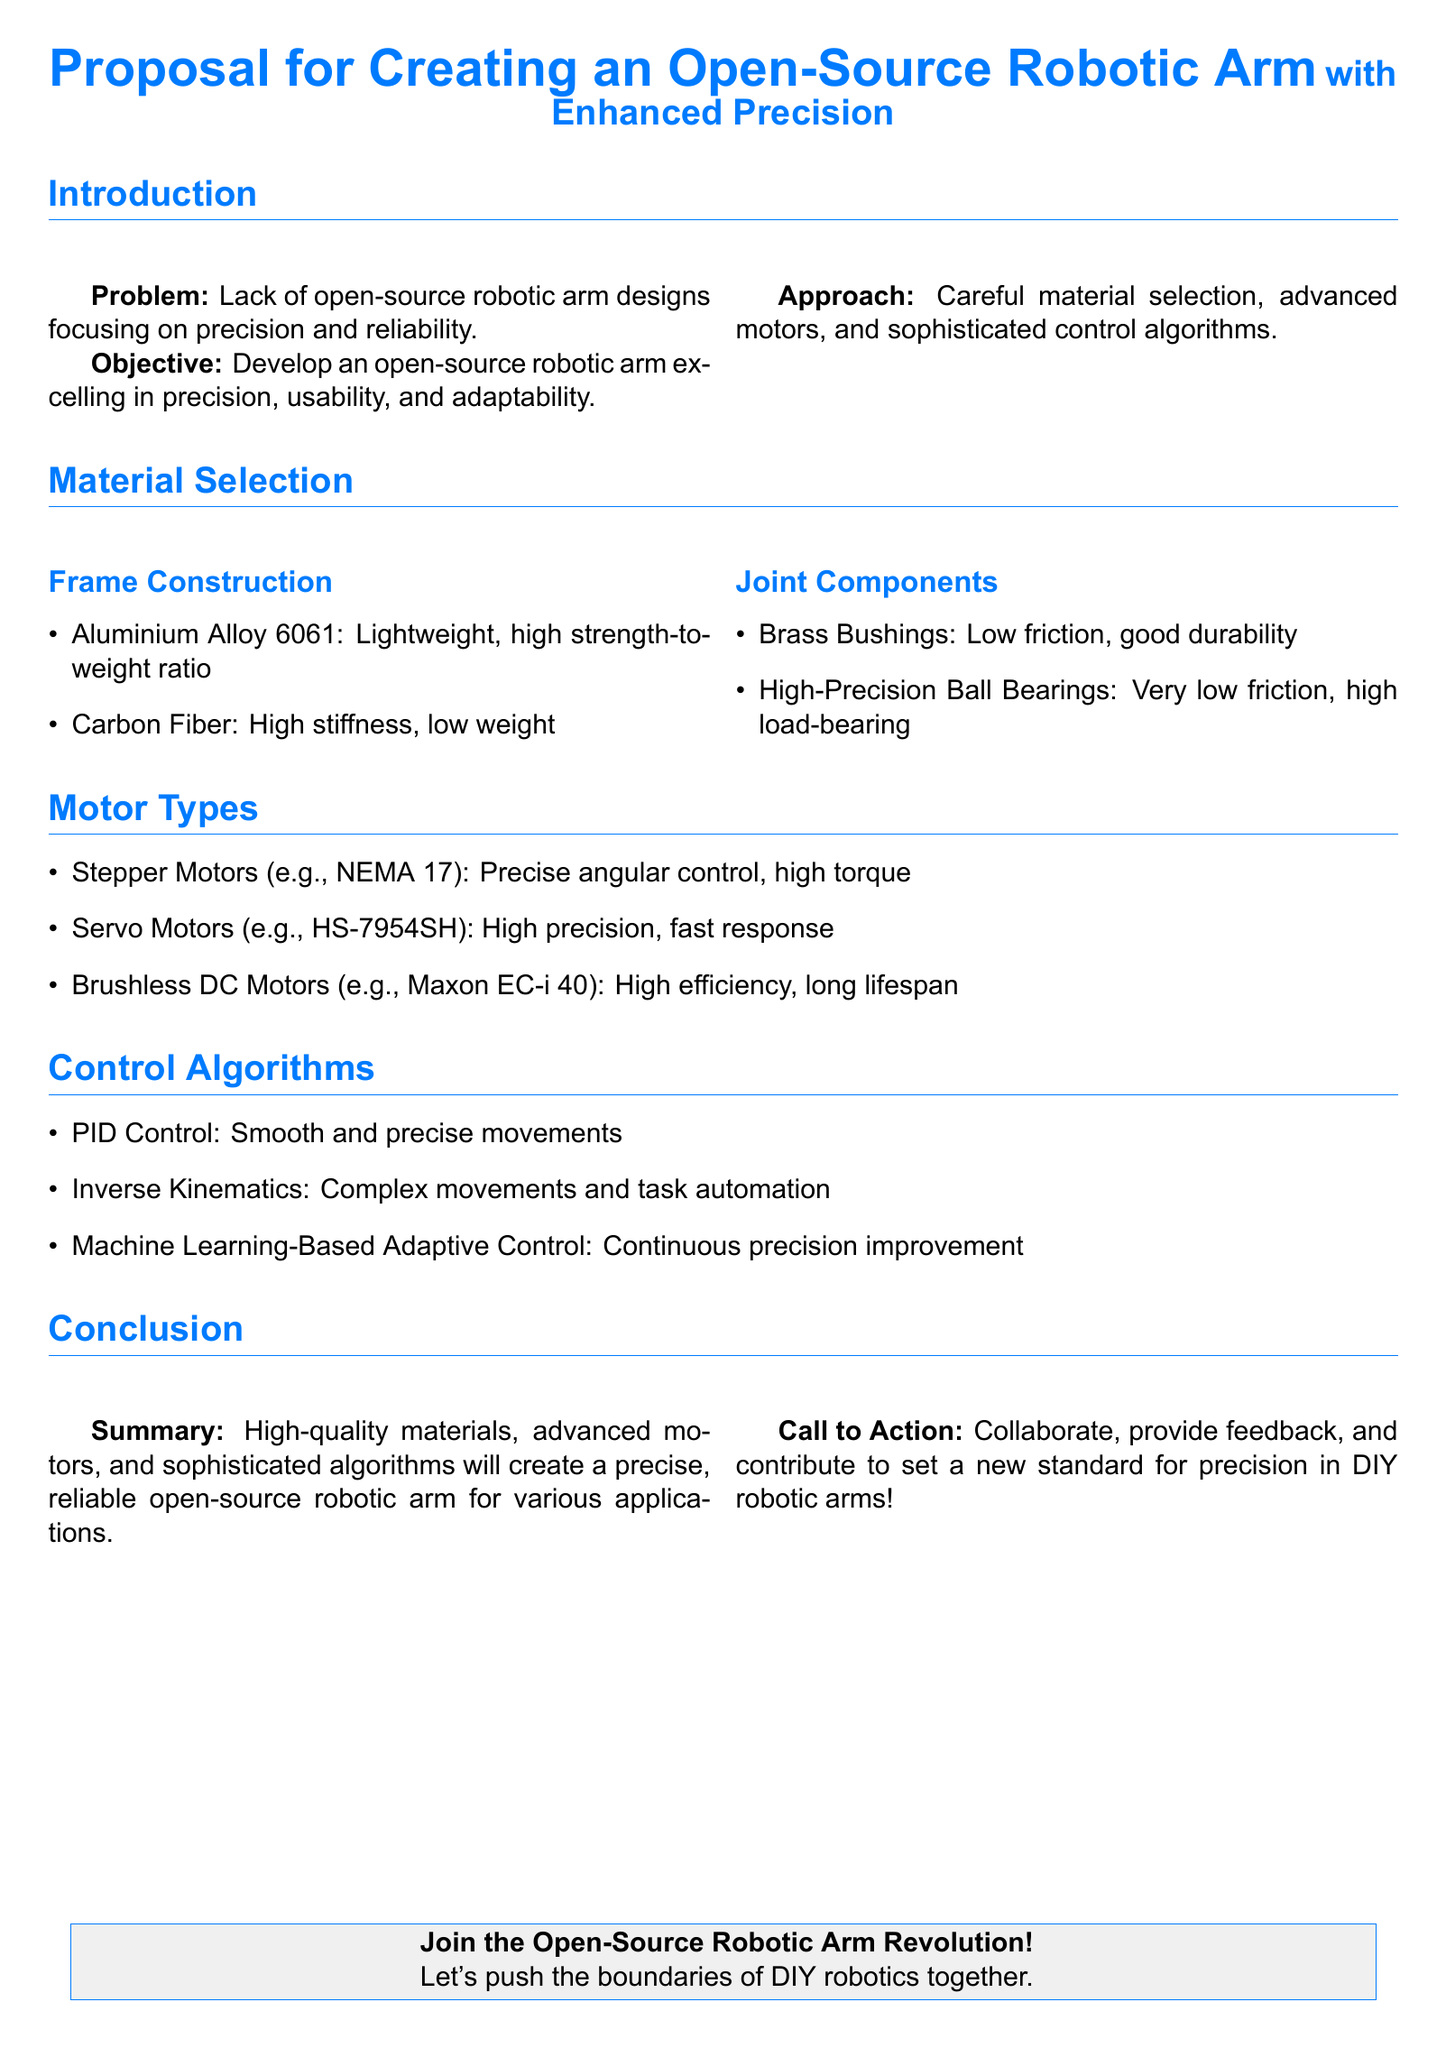What is the main problem addressed in the proposal? The document states that there is a lack of open-source robotic arm designs focusing on precision and reliability.
Answer: Lack of open-source robotic arm designs What material is suggested for the frame construction? The proposal lists aluminium alloy 6061 and carbon fiber as materials for frame construction.
Answer: Aluminium Alloy 6061 What type of motors does the proposal suggest for precision? The document details stepper motors, servo motors, and brushless DC motors for precise control.
Answer: Stepper Motors What control algorithm is recommended for smooth movements? The proposal mentions PID control as a method for achieving smooth and precise movements.
Answer: PID Control What high-precision components are recommended for joint components? The document suggests using brass bushings and high-precision ball bearings for joint components.
Answer: High-Precision Ball Bearings What is the objective of the proposal? The objective outlined in the document is to develop an open-source robotic arm excelling in precision, usability, and adaptability.
Answer: Develop an open-source robotic arm What is the intended call to action in the conclusion? The conclusion encourages readers to collaborate, provide feedback, and contribute to the project.
Answer: Collaborate, provide feedback How many types of motors are mentioned in the document? The document lists three types of motors: stepper motors, servo motors, and brushless DC motors.
Answer: Three What is one of the advanced controls suggested for automating tasks? The proposal states that inverse kinematics is recommended for complex movements and task automation.
Answer: Inverse Kinematics 